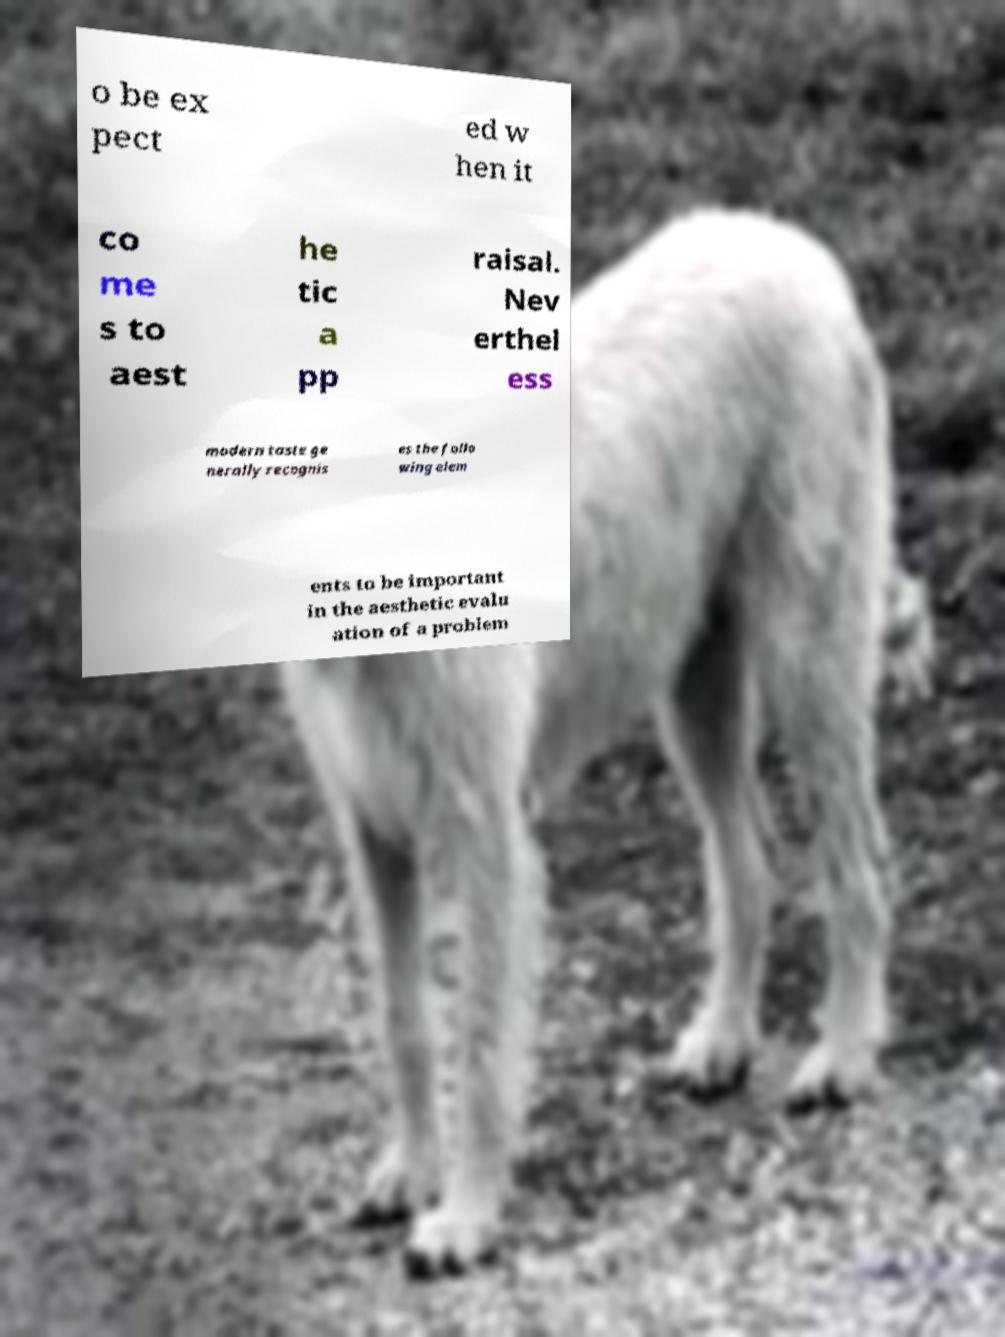For documentation purposes, I need the text within this image transcribed. Could you provide that? o be ex pect ed w hen it co me s to aest he tic a pp raisal. Nev erthel ess modern taste ge nerally recognis es the follo wing elem ents to be important in the aesthetic evalu ation of a problem 